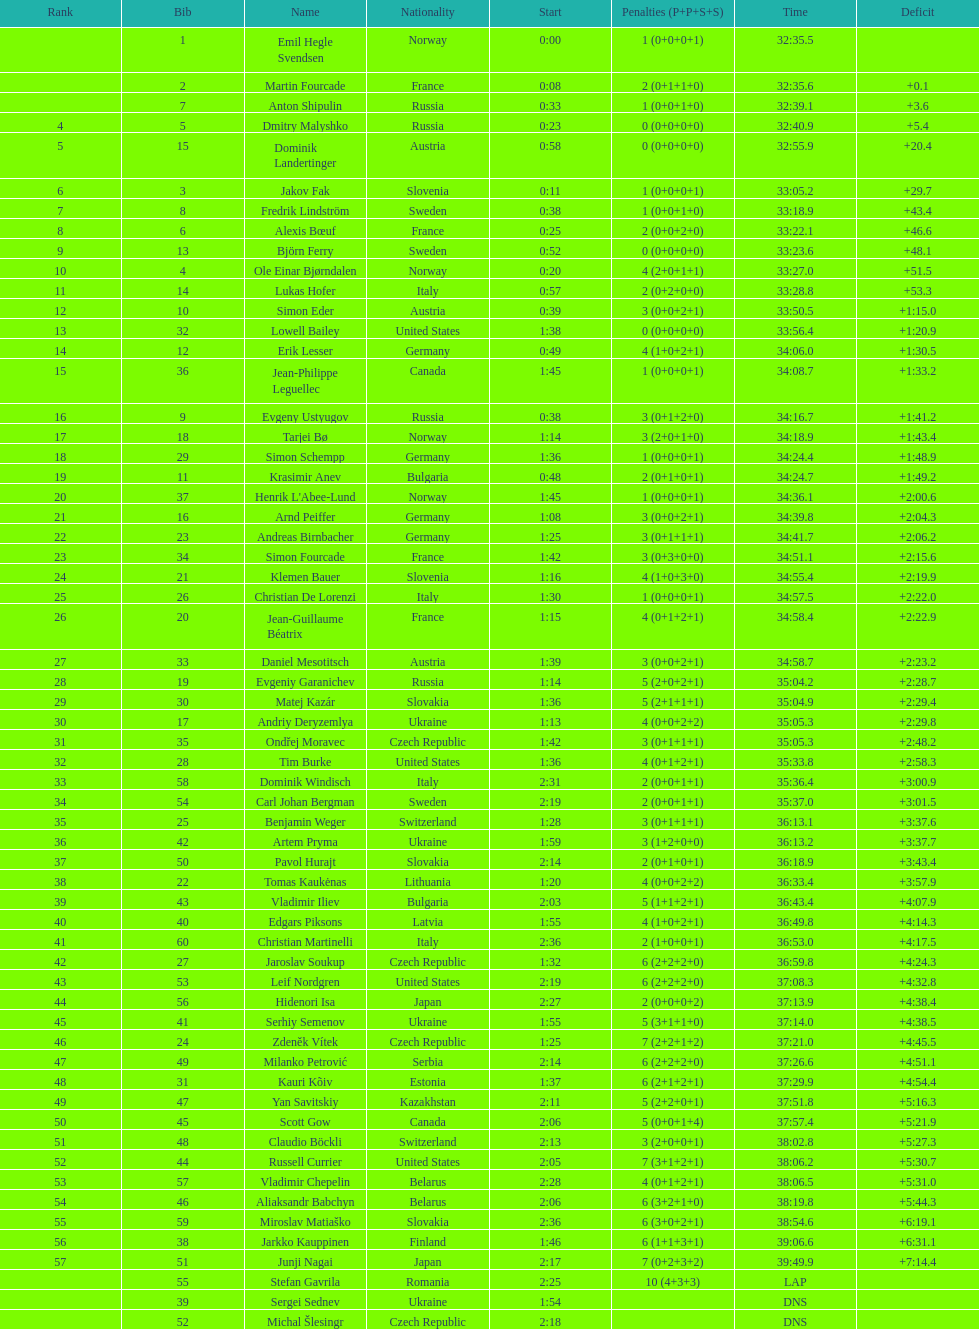How long did it take for erik lesser to finish? 34:06.0. 